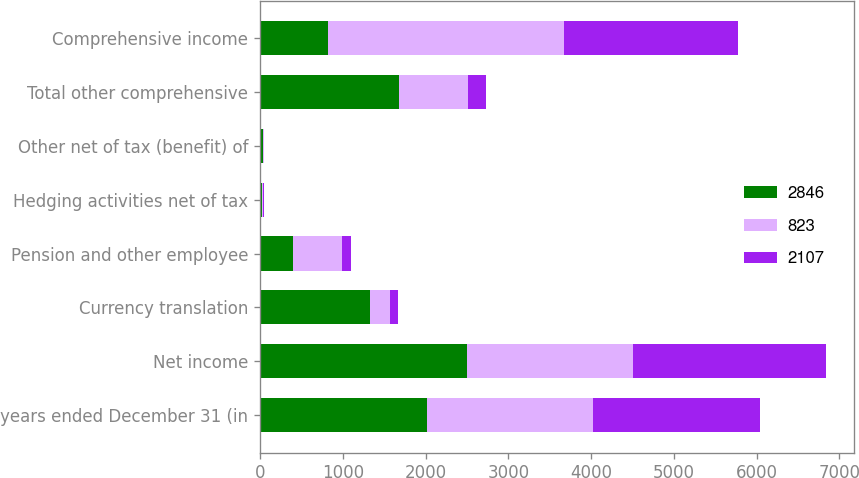<chart> <loc_0><loc_0><loc_500><loc_500><stacked_bar_chart><ecel><fcel>years ended December 31 (in<fcel>Net income<fcel>Currency translation<fcel>Pension and other employee<fcel>Hedging activities net of tax<fcel>Other net of tax (benefit) of<fcel>Total other comprehensive<fcel>Comprehensive income<nl><fcel>2846<fcel>2014<fcel>2497<fcel>1332<fcel>400<fcel>24<fcel>34<fcel>1674<fcel>823<nl><fcel>823<fcel>2013<fcel>2012<fcel>236<fcel>592<fcel>15<fcel>9<fcel>834<fcel>2846<nl><fcel>2107<fcel>2012<fcel>2326<fcel>98<fcel>111<fcel>7<fcel>3<fcel>219<fcel>2107<nl></chart> 